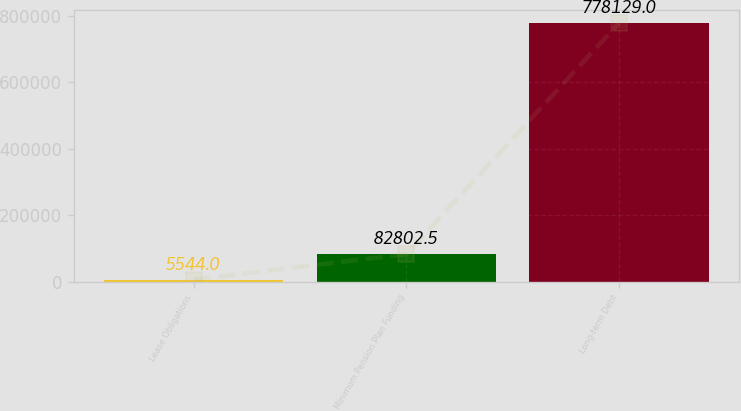<chart> <loc_0><loc_0><loc_500><loc_500><bar_chart><fcel>Lease Obligations<fcel>Minimum Pension Plan Funding<fcel>Long-term Debt<nl><fcel>5544<fcel>82802.5<fcel>778129<nl></chart> 